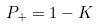<formula> <loc_0><loc_0><loc_500><loc_500>P _ { + } = 1 - K</formula> 